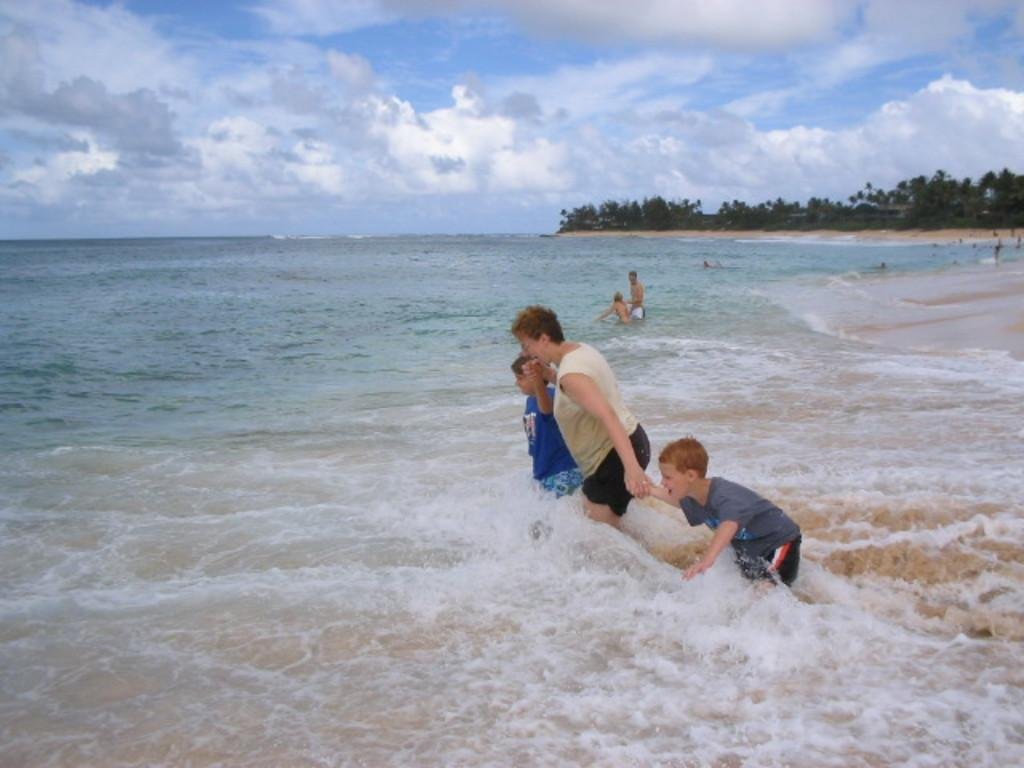What is at the bottom of the image? There is water at the bottom of the image. What can be seen in the middle of the image? There are people in the middle of the image. What type of vegetation is visible in the background of the image? There are trees in the background of the image. What is visible at the top of the image? The sky is visible at the top of the image. What can be observed in the sky? Clouds are present in the sky. Where is the church located in the image? There is no church present in the image. What type of fowl can be seen in the image? There are no fowl visible in the image. 